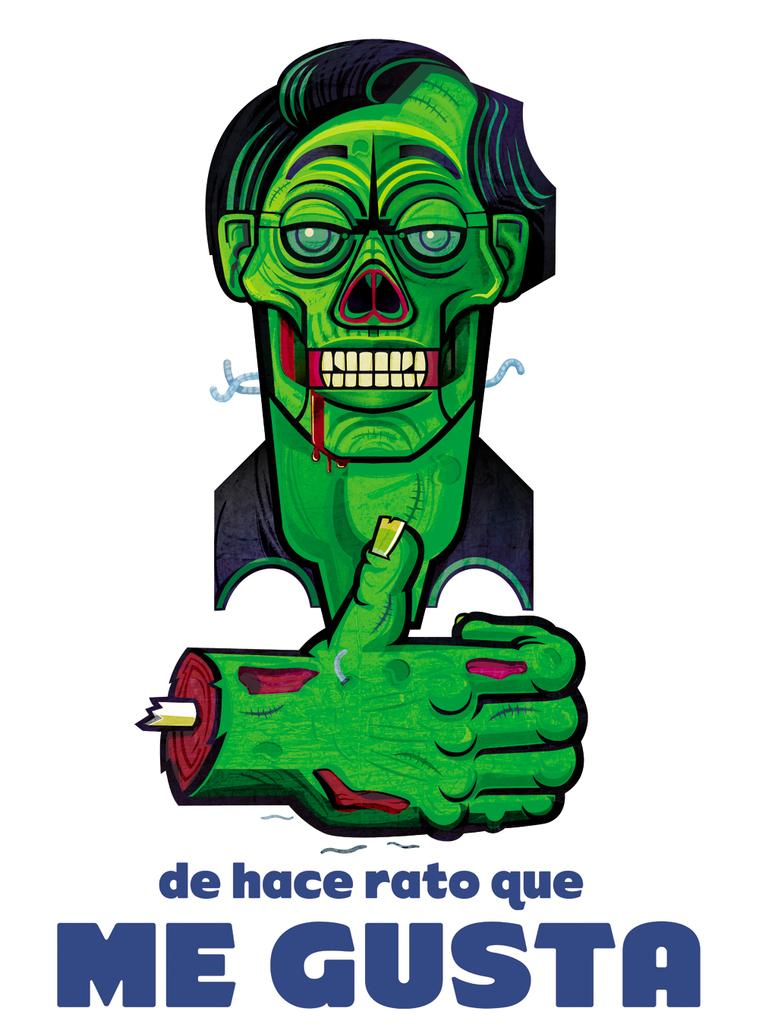What type of content is depicted in the image? There is a cartoon in the image. Is there any text associated with the cartoon? Yes, there is text at the bottom of the image. What type of brass instrument can be heard playing in the background of the image? There is no brass instrument or sound present in the image, as it features a cartoon and text. 